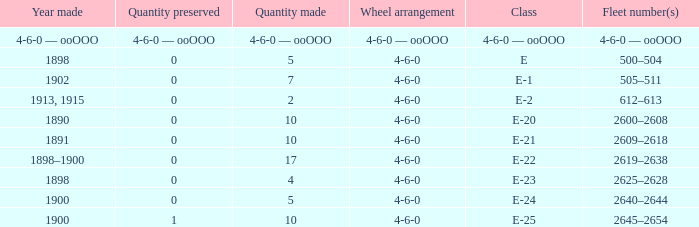What is the wheel arrangement with 1 quantity preserved? 4-6-0. 